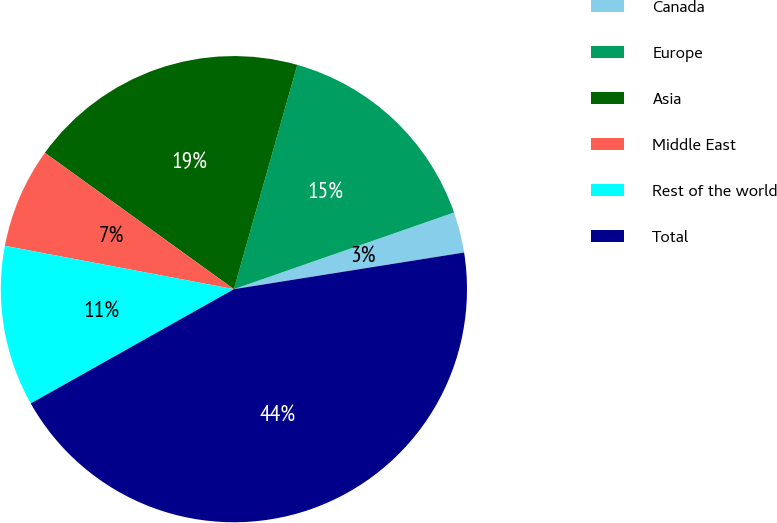Convert chart to OTSL. <chart><loc_0><loc_0><loc_500><loc_500><pie_chart><fcel>Canada<fcel>Europe<fcel>Asia<fcel>Middle East<fcel>Rest of the world<fcel>Total<nl><fcel>2.82%<fcel>15.28%<fcel>19.44%<fcel>6.97%<fcel>11.13%<fcel>44.36%<nl></chart> 